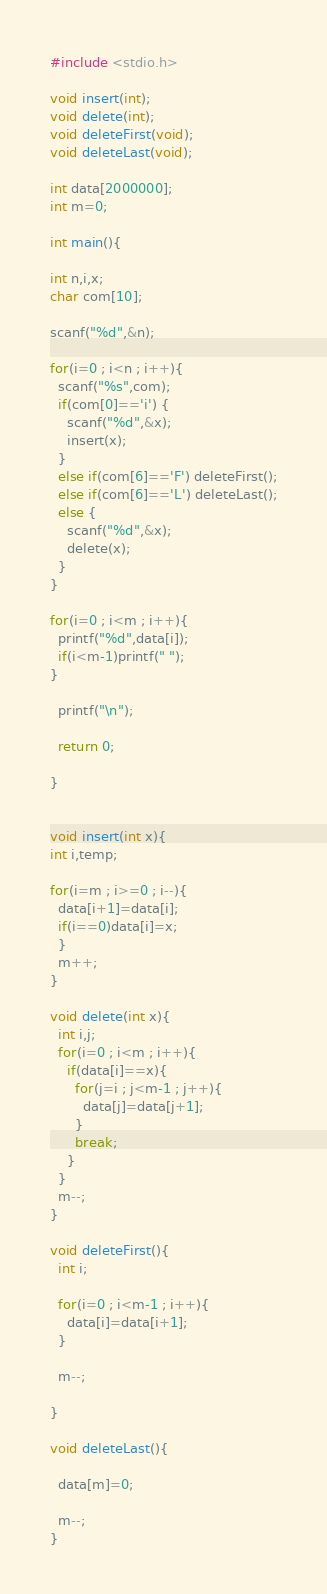Convert code to text. <code><loc_0><loc_0><loc_500><loc_500><_C_>#include <stdio.h>

void insert(int);
void delete(int);
void deleteFirst(void);
void deleteLast(void);

int data[2000000];
int m=0;

int main(){

int n,i,x;
char com[10];

scanf("%d",&n);

for(i=0 ; i<n ; i++){
  scanf("%s",com);
  if(com[0]=='i') {
    scanf("%d",&x);
    insert(x);
  }
  else if(com[6]=='F') deleteFirst();
  else if(com[6]=='L') deleteLast();
  else {
    scanf("%d",&x);
    delete(x);
  }
}

for(i=0 ; i<m ; i++){
  printf("%d",data[i]);
  if(i<m-1)printf(" ");
}

  printf("\n");

  return 0;

}


void insert(int x){
int i,temp;

for(i=m ; i>=0 ; i--){
  data[i+1]=data[i];
  if(i==0)data[i]=x;
  }
  m++;
}

void delete(int x){
  int i,j;
  for(i=0 ; i<m ; i++){
    if(data[i]==x){
      for(j=i ; j<m-1 ; j++){
        data[j]=data[j+1];
      }
      break;
    }
  }
  m--;
}

void deleteFirst(){
  int i;

  for(i=0 ; i<m-1 ; i++){
    data[i]=data[i+1];
  }

  m--;

}

void deleteLast(){

  data[m]=0;

  m--;
}</code> 